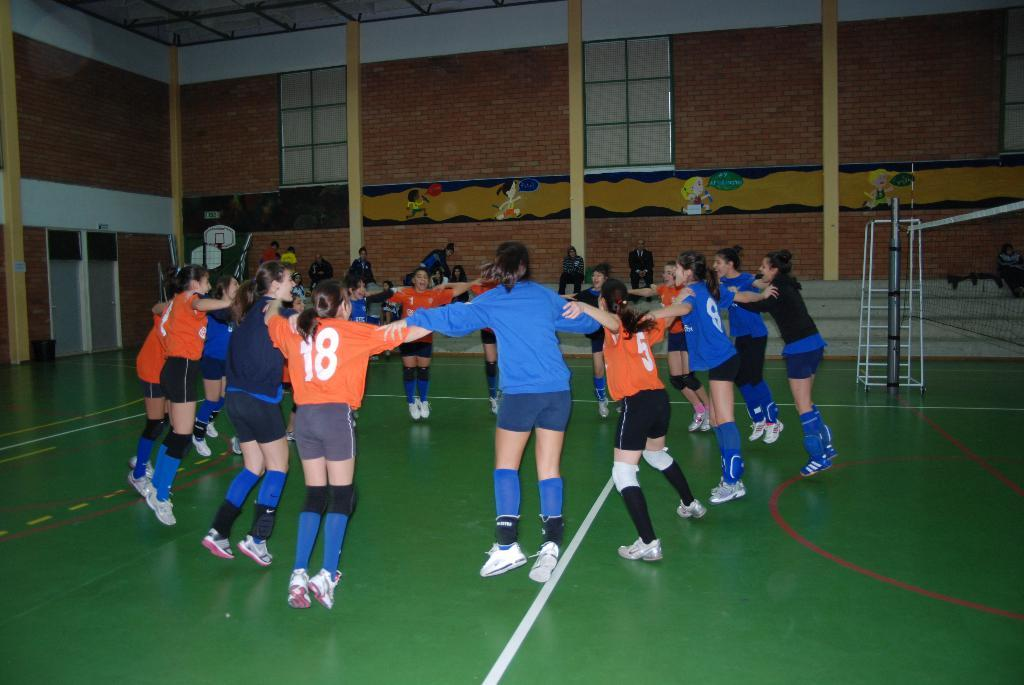<image>
Create a compact narrative representing the image presented. a person with an orange shirt that has the number 18 on it 